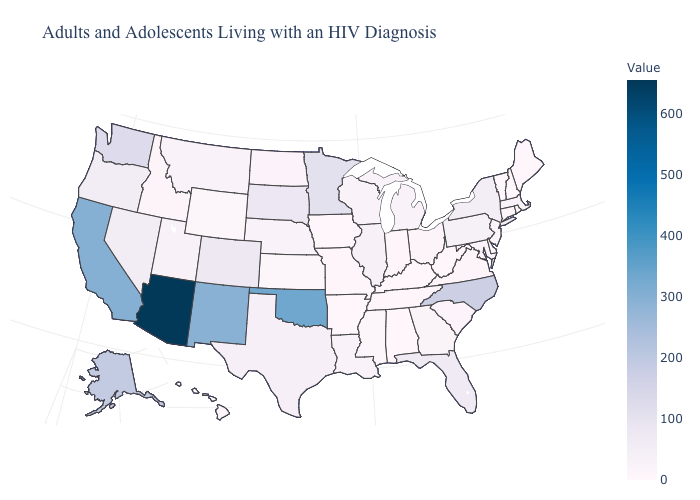Among the states that border Virginia , does West Virginia have the lowest value?
Short answer required. Yes. Does the map have missing data?
Quick response, please. No. Is the legend a continuous bar?
Give a very brief answer. Yes. Which states hav the highest value in the West?
Answer briefly. Arizona. Does New Mexico have the highest value in the West?
Short answer required. No. Among the states that border North Dakota , does South Dakota have the highest value?
Short answer required. No. Is the legend a continuous bar?
Give a very brief answer. Yes. Among the states that border Rhode Island , which have the lowest value?
Answer briefly. Connecticut. Which states have the lowest value in the MidWest?
Quick response, please. Iowa. 